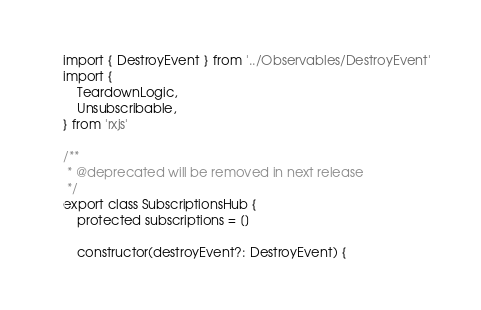Convert code to text. <code><loc_0><loc_0><loc_500><loc_500><_TypeScript_>import { DestroyEvent } from '../Observables/DestroyEvent'
import {
    TeardownLogic,
    Unsubscribable,
} from 'rxjs'

/**
 * @deprecated will be removed in next release
 */
export class SubscriptionsHub {
    protected subscriptions = []

    constructor(destroyEvent?: DestroyEvent) {</code> 